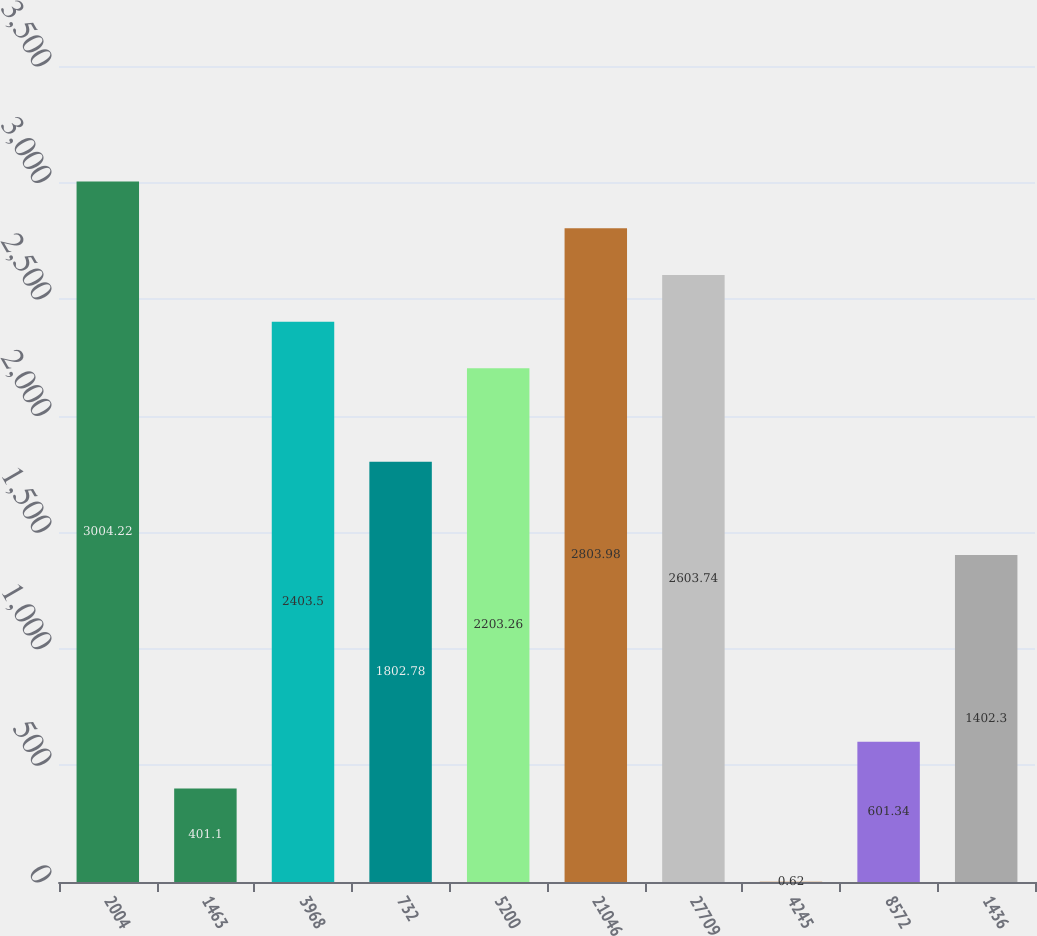<chart> <loc_0><loc_0><loc_500><loc_500><bar_chart><fcel>2004<fcel>1463<fcel>3968<fcel>732<fcel>5200<fcel>21046<fcel>27709<fcel>4245<fcel>8572<fcel>1436<nl><fcel>3004.22<fcel>401.1<fcel>2403.5<fcel>1802.78<fcel>2203.26<fcel>2803.98<fcel>2603.74<fcel>0.62<fcel>601.34<fcel>1402.3<nl></chart> 